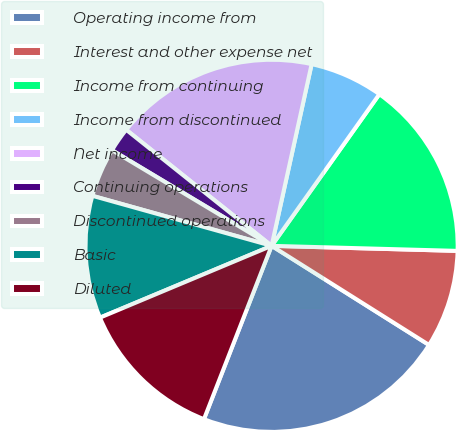<chart> <loc_0><loc_0><loc_500><loc_500><pie_chart><fcel>Operating income from<fcel>Interest and other expense net<fcel>Income from continuing<fcel>Income from discontinued<fcel>Net income<fcel>Continuing operations<fcel>Discontinued operations<fcel>Basic<fcel>Diluted<nl><fcel>21.98%<fcel>8.51%<fcel>15.6%<fcel>6.38%<fcel>17.73%<fcel>2.13%<fcel>4.26%<fcel>10.64%<fcel>12.77%<nl></chart> 